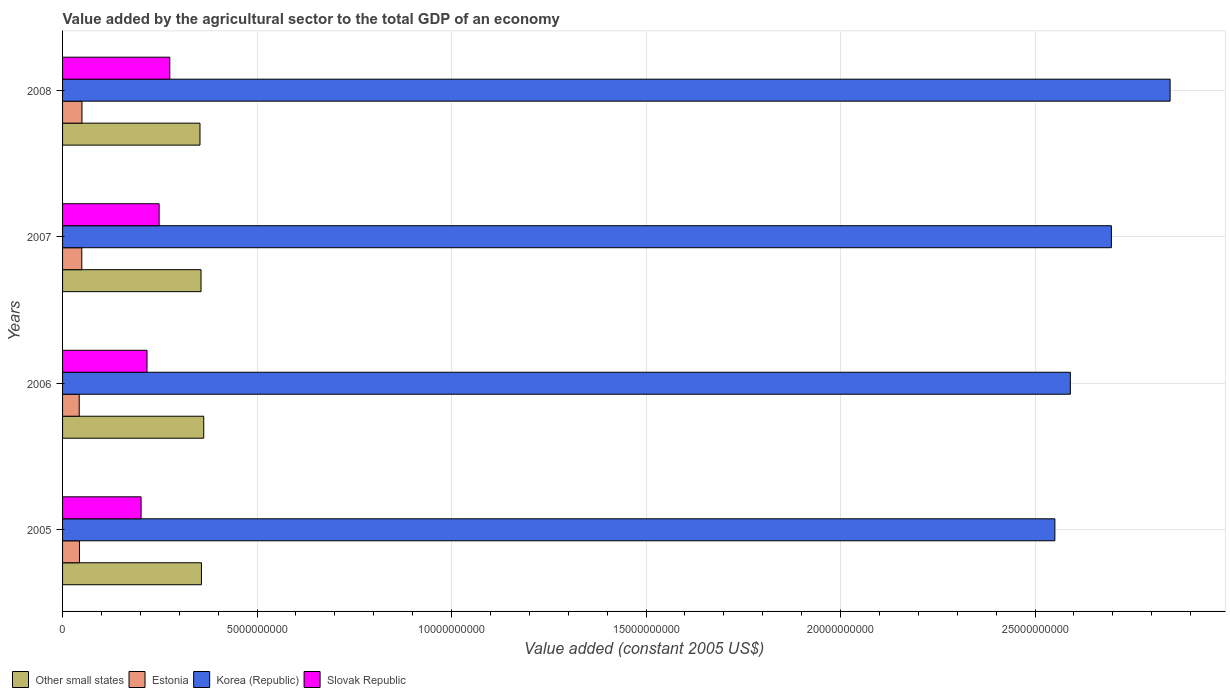Are the number of bars per tick equal to the number of legend labels?
Ensure brevity in your answer.  Yes. Are the number of bars on each tick of the Y-axis equal?
Ensure brevity in your answer.  Yes. How many bars are there on the 4th tick from the top?
Provide a short and direct response. 4. In how many cases, is the number of bars for a given year not equal to the number of legend labels?
Provide a short and direct response. 0. What is the value added by the agricultural sector in Korea (Republic) in 2005?
Your answer should be compact. 2.55e+1. Across all years, what is the maximum value added by the agricultural sector in Slovak Republic?
Provide a succinct answer. 2.76e+09. Across all years, what is the minimum value added by the agricultural sector in Estonia?
Your response must be concise. 4.28e+08. In which year was the value added by the agricultural sector in Slovak Republic maximum?
Give a very brief answer. 2008. In which year was the value added by the agricultural sector in Other small states minimum?
Your answer should be compact. 2008. What is the total value added by the agricultural sector in Slovak Republic in the graph?
Provide a succinct answer. 9.43e+09. What is the difference between the value added by the agricultural sector in Estonia in 2005 and that in 2007?
Your answer should be compact. -6.01e+07. What is the difference between the value added by the agricultural sector in Estonia in 2006 and the value added by the agricultural sector in Slovak Republic in 2008?
Offer a very short reply. -2.33e+09. What is the average value added by the agricultural sector in Other small states per year?
Your response must be concise. 3.57e+09. In the year 2008, what is the difference between the value added by the agricultural sector in Slovak Republic and value added by the agricultural sector in Estonia?
Your response must be concise. 2.26e+09. What is the ratio of the value added by the agricultural sector in Other small states in 2007 to that in 2008?
Your answer should be compact. 1.01. Is the value added by the agricultural sector in Estonia in 2007 less than that in 2008?
Ensure brevity in your answer.  Yes. Is the difference between the value added by the agricultural sector in Slovak Republic in 2005 and 2007 greater than the difference between the value added by the agricultural sector in Estonia in 2005 and 2007?
Your answer should be very brief. No. What is the difference between the highest and the second highest value added by the agricultural sector in Slovak Republic?
Provide a short and direct response. 2.74e+08. What is the difference between the highest and the lowest value added by the agricultural sector in Korea (Republic)?
Give a very brief answer. 2.96e+09. Is the sum of the value added by the agricultural sector in Estonia in 2005 and 2006 greater than the maximum value added by the agricultural sector in Other small states across all years?
Your answer should be compact. No. Is it the case that in every year, the sum of the value added by the agricultural sector in Other small states and value added by the agricultural sector in Korea (Republic) is greater than the sum of value added by the agricultural sector in Estonia and value added by the agricultural sector in Slovak Republic?
Give a very brief answer. Yes. What does the 4th bar from the top in 2008 represents?
Provide a succinct answer. Other small states. What does the 1st bar from the bottom in 2008 represents?
Provide a succinct answer. Other small states. Is it the case that in every year, the sum of the value added by the agricultural sector in Slovak Republic and value added by the agricultural sector in Estonia is greater than the value added by the agricultural sector in Korea (Republic)?
Ensure brevity in your answer.  No. How many bars are there?
Make the answer very short. 16. Are all the bars in the graph horizontal?
Give a very brief answer. Yes. How many years are there in the graph?
Make the answer very short. 4. What is the difference between two consecutive major ticks on the X-axis?
Give a very brief answer. 5.00e+09. Does the graph contain any zero values?
Your response must be concise. No. Where does the legend appear in the graph?
Ensure brevity in your answer.  Bottom left. How are the legend labels stacked?
Ensure brevity in your answer.  Horizontal. What is the title of the graph?
Your answer should be compact. Value added by the agricultural sector to the total GDP of an economy. What is the label or title of the X-axis?
Offer a very short reply. Value added (constant 2005 US$). What is the Value added (constant 2005 US$) of Other small states in 2005?
Your response must be concise. 3.57e+09. What is the Value added (constant 2005 US$) of Estonia in 2005?
Provide a succinct answer. 4.34e+08. What is the Value added (constant 2005 US$) of Korea (Republic) in 2005?
Give a very brief answer. 2.55e+1. What is the Value added (constant 2005 US$) in Slovak Republic in 2005?
Ensure brevity in your answer.  2.02e+09. What is the Value added (constant 2005 US$) of Other small states in 2006?
Ensure brevity in your answer.  3.63e+09. What is the Value added (constant 2005 US$) of Estonia in 2006?
Ensure brevity in your answer.  4.28e+08. What is the Value added (constant 2005 US$) of Korea (Republic) in 2006?
Ensure brevity in your answer.  2.59e+1. What is the Value added (constant 2005 US$) in Slovak Republic in 2006?
Make the answer very short. 2.17e+09. What is the Value added (constant 2005 US$) in Other small states in 2007?
Keep it short and to the point. 3.56e+09. What is the Value added (constant 2005 US$) in Estonia in 2007?
Offer a very short reply. 4.94e+08. What is the Value added (constant 2005 US$) of Korea (Republic) in 2007?
Your answer should be compact. 2.70e+1. What is the Value added (constant 2005 US$) of Slovak Republic in 2007?
Offer a terse response. 2.48e+09. What is the Value added (constant 2005 US$) of Other small states in 2008?
Offer a terse response. 3.53e+09. What is the Value added (constant 2005 US$) in Estonia in 2008?
Provide a short and direct response. 4.99e+08. What is the Value added (constant 2005 US$) in Korea (Republic) in 2008?
Ensure brevity in your answer.  2.85e+1. What is the Value added (constant 2005 US$) in Slovak Republic in 2008?
Your response must be concise. 2.76e+09. Across all years, what is the maximum Value added (constant 2005 US$) of Other small states?
Your response must be concise. 3.63e+09. Across all years, what is the maximum Value added (constant 2005 US$) of Estonia?
Give a very brief answer. 4.99e+08. Across all years, what is the maximum Value added (constant 2005 US$) in Korea (Republic)?
Keep it short and to the point. 2.85e+1. Across all years, what is the maximum Value added (constant 2005 US$) of Slovak Republic?
Keep it short and to the point. 2.76e+09. Across all years, what is the minimum Value added (constant 2005 US$) of Other small states?
Offer a terse response. 3.53e+09. Across all years, what is the minimum Value added (constant 2005 US$) in Estonia?
Provide a short and direct response. 4.28e+08. Across all years, what is the minimum Value added (constant 2005 US$) in Korea (Republic)?
Provide a succinct answer. 2.55e+1. Across all years, what is the minimum Value added (constant 2005 US$) of Slovak Republic?
Make the answer very short. 2.02e+09. What is the total Value added (constant 2005 US$) in Other small states in the graph?
Offer a terse response. 1.43e+1. What is the total Value added (constant 2005 US$) in Estonia in the graph?
Provide a succinct answer. 1.86e+09. What is the total Value added (constant 2005 US$) in Korea (Republic) in the graph?
Ensure brevity in your answer.  1.07e+11. What is the total Value added (constant 2005 US$) in Slovak Republic in the graph?
Your response must be concise. 9.43e+09. What is the difference between the Value added (constant 2005 US$) of Other small states in 2005 and that in 2006?
Offer a terse response. -5.84e+07. What is the difference between the Value added (constant 2005 US$) of Estonia in 2005 and that in 2006?
Offer a very short reply. 5.99e+06. What is the difference between the Value added (constant 2005 US$) in Korea (Republic) in 2005 and that in 2006?
Your response must be concise. -3.98e+08. What is the difference between the Value added (constant 2005 US$) of Slovak Republic in 2005 and that in 2006?
Give a very brief answer. -1.52e+08. What is the difference between the Value added (constant 2005 US$) in Other small states in 2005 and that in 2007?
Your answer should be compact. 1.07e+07. What is the difference between the Value added (constant 2005 US$) of Estonia in 2005 and that in 2007?
Your answer should be very brief. -6.01e+07. What is the difference between the Value added (constant 2005 US$) of Korea (Republic) in 2005 and that in 2007?
Your response must be concise. -1.45e+09. What is the difference between the Value added (constant 2005 US$) in Slovak Republic in 2005 and that in 2007?
Ensure brevity in your answer.  -4.64e+08. What is the difference between the Value added (constant 2005 US$) in Other small states in 2005 and that in 2008?
Make the answer very short. 3.79e+07. What is the difference between the Value added (constant 2005 US$) of Estonia in 2005 and that in 2008?
Offer a very short reply. -6.44e+07. What is the difference between the Value added (constant 2005 US$) in Korea (Republic) in 2005 and that in 2008?
Your answer should be compact. -2.96e+09. What is the difference between the Value added (constant 2005 US$) of Slovak Republic in 2005 and that in 2008?
Your answer should be very brief. -7.38e+08. What is the difference between the Value added (constant 2005 US$) of Other small states in 2006 and that in 2007?
Offer a terse response. 6.91e+07. What is the difference between the Value added (constant 2005 US$) in Estonia in 2006 and that in 2007?
Your answer should be compact. -6.61e+07. What is the difference between the Value added (constant 2005 US$) in Korea (Republic) in 2006 and that in 2007?
Your response must be concise. -1.05e+09. What is the difference between the Value added (constant 2005 US$) of Slovak Republic in 2006 and that in 2007?
Make the answer very short. -3.12e+08. What is the difference between the Value added (constant 2005 US$) in Other small states in 2006 and that in 2008?
Offer a very short reply. 9.63e+07. What is the difference between the Value added (constant 2005 US$) of Estonia in 2006 and that in 2008?
Keep it short and to the point. -7.04e+07. What is the difference between the Value added (constant 2005 US$) in Korea (Republic) in 2006 and that in 2008?
Your answer should be compact. -2.56e+09. What is the difference between the Value added (constant 2005 US$) in Slovak Republic in 2006 and that in 2008?
Ensure brevity in your answer.  -5.86e+08. What is the difference between the Value added (constant 2005 US$) in Other small states in 2007 and that in 2008?
Make the answer very short. 2.72e+07. What is the difference between the Value added (constant 2005 US$) of Estonia in 2007 and that in 2008?
Offer a terse response. -4.29e+06. What is the difference between the Value added (constant 2005 US$) of Korea (Republic) in 2007 and that in 2008?
Offer a very short reply. -1.51e+09. What is the difference between the Value added (constant 2005 US$) in Slovak Republic in 2007 and that in 2008?
Offer a terse response. -2.74e+08. What is the difference between the Value added (constant 2005 US$) of Other small states in 2005 and the Value added (constant 2005 US$) of Estonia in 2006?
Make the answer very short. 3.14e+09. What is the difference between the Value added (constant 2005 US$) of Other small states in 2005 and the Value added (constant 2005 US$) of Korea (Republic) in 2006?
Your response must be concise. -2.23e+1. What is the difference between the Value added (constant 2005 US$) of Other small states in 2005 and the Value added (constant 2005 US$) of Slovak Republic in 2006?
Ensure brevity in your answer.  1.40e+09. What is the difference between the Value added (constant 2005 US$) in Estonia in 2005 and the Value added (constant 2005 US$) in Korea (Republic) in 2006?
Provide a succinct answer. -2.55e+1. What is the difference between the Value added (constant 2005 US$) of Estonia in 2005 and the Value added (constant 2005 US$) of Slovak Republic in 2006?
Your answer should be compact. -1.74e+09. What is the difference between the Value added (constant 2005 US$) in Korea (Republic) in 2005 and the Value added (constant 2005 US$) in Slovak Republic in 2006?
Offer a terse response. 2.33e+1. What is the difference between the Value added (constant 2005 US$) of Other small states in 2005 and the Value added (constant 2005 US$) of Estonia in 2007?
Offer a very short reply. 3.08e+09. What is the difference between the Value added (constant 2005 US$) of Other small states in 2005 and the Value added (constant 2005 US$) of Korea (Republic) in 2007?
Offer a very short reply. -2.34e+1. What is the difference between the Value added (constant 2005 US$) in Other small states in 2005 and the Value added (constant 2005 US$) in Slovak Republic in 2007?
Your answer should be compact. 1.09e+09. What is the difference between the Value added (constant 2005 US$) in Estonia in 2005 and the Value added (constant 2005 US$) in Korea (Republic) in 2007?
Offer a terse response. -2.65e+1. What is the difference between the Value added (constant 2005 US$) in Estonia in 2005 and the Value added (constant 2005 US$) in Slovak Republic in 2007?
Provide a short and direct response. -2.05e+09. What is the difference between the Value added (constant 2005 US$) of Korea (Republic) in 2005 and the Value added (constant 2005 US$) of Slovak Republic in 2007?
Offer a terse response. 2.30e+1. What is the difference between the Value added (constant 2005 US$) in Other small states in 2005 and the Value added (constant 2005 US$) in Estonia in 2008?
Your response must be concise. 3.07e+09. What is the difference between the Value added (constant 2005 US$) of Other small states in 2005 and the Value added (constant 2005 US$) of Korea (Republic) in 2008?
Offer a terse response. -2.49e+1. What is the difference between the Value added (constant 2005 US$) of Other small states in 2005 and the Value added (constant 2005 US$) of Slovak Republic in 2008?
Provide a short and direct response. 8.14e+08. What is the difference between the Value added (constant 2005 US$) in Estonia in 2005 and the Value added (constant 2005 US$) in Korea (Republic) in 2008?
Your answer should be compact. -2.80e+1. What is the difference between the Value added (constant 2005 US$) in Estonia in 2005 and the Value added (constant 2005 US$) in Slovak Republic in 2008?
Your answer should be compact. -2.32e+09. What is the difference between the Value added (constant 2005 US$) of Korea (Republic) in 2005 and the Value added (constant 2005 US$) of Slovak Republic in 2008?
Make the answer very short. 2.28e+1. What is the difference between the Value added (constant 2005 US$) of Other small states in 2006 and the Value added (constant 2005 US$) of Estonia in 2007?
Your response must be concise. 3.13e+09. What is the difference between the Value added (constant 2005 US$) of Other small states in 2006 and the Value added (constant 2005 US$) of Korea (Republic) in 2007?
Provide a short and direct response. -2.33e+1. What is the difference between the Value added (constant 2005 US$) in Other small states in 2006 and the Value added (constant 2005 US$) in Slovak Republic in 2007?
Make the answer very short. 1.15e+09. What is the difference between the Value added (constant 2005 US$) of Estonia in 2006 and the Value added (constant 2005 US$) of Korea (Republic) in 2007?
Offer a terse response. -2.65e+1. What is the difference between the Value added (constant 2005 US$) of Estonia in 2006 and the Value added (constant 2005 US$) of Slovak Republic in 2007?
Make the answer very short. -2.05e+09. What is the difference between the Value added (constant 2005 US$) in Korea (Republic) in 2006 and the Value added (constant 2005 US$) in Slovak Republic in 2007?
Give a very brief answer. 2.34e+1. What is the difference between the Value added (constant 2005 US$) of Other small states in 2006 and the Value added (constant 2005 US$) of Estonia in 2008?
Your answer should be compact. 3.13e+09. What is the difference between the Value added (constant 2005 US$) of Other small states in 2006 and the Value added (constant 2005 US$) of Korea (Republic) in 2008?
Provide a succinct answer. -2.48e+1. What is the difference between the Value added (constant 2005 US$) in Other small states in 2006 and the Value added (constant 2005 US$) in Slovak Republic in 2008?
Give a very brief answer. 8.72e+08. What is the difference between the Value added (constant 2005 US$) of Estonia in 2006 and the Value added (constant 2005 US$) of Korea (Republic) in 2008?
Make the answer very short. -2.80e+1. What is the difference between the Value added (constant 2005 US$) in Estonia in 2006 and the Value added (constant 2005 US$) in Slovak Republic in 2008?
Offer a very short reply. -2.33e+09. What is the difference between the Value added (constant 2005 US$) of Korea (Republic) in 2006 and the Value added (constant 2005 US$) of Slovak Republic in 2008?
Provide a short and direct response. 2.32e+1. What is the difference between the Value added (constant 2005 US$) of Other small states in 2007 and the Value added (constant 2005 US$) of Estonia in 2008?
Your answer should be compact. 3.06e+09. What is the difference between the Value added (constant 2005 US$) of Other small states in 2007 and the Value added (constant 2005 US$) of Korea (Republic) in 2008?
Keep it short and to the point. -2.49e+1. What is the difference between the Value added (constant 2005 US$) in Other small states in 2007 and the Value added (constant 2005 US$) in Slovak Republic in 2008?
Provide a succinct answer. 8.03e+08. What is the difference between the Value added (constant 2005 US$) of Estonia in 2007 and the Value added (constant 2005 US$) of Korea (Republic) in 2008?
Your answer should be very brief. -2.80e+1. What is the difference between the Value added (constant 2005 US$) of Estonia in 2007 and the Value added (constant 2005 US$) of Slovak Republic in 2008?
Ensure brevity in your answer.  -2.26e+09. What is the difference between the Value added (constant 2005 US$) of Korea (Republic) in 2007 and the Value added (constant 2005 US$) of Slovak Republic in 2008?
Keep it short and to the point. 2.42e+1. What is the average Value added (constant 2005 US$) in Other small states per year?
Ensure brevity in your answer.  3.57e+09. What is the average Value added (constant 2005 US$) of Estonia per year?
Ensure brevity in your answer.  4.64e+08. What is the average Value added (constant 2005 US$) in Korea (Republic) per year?
Provide a short and direct response. 2.67e+1. What is the average Value added (constant 2005 US$) of Slovak Republic per year?
Your answer should be very brief. 2.36e+09. In the year 2005, what is the difference between the Value added (constant 2005 US$) of Other small states and Value added (constant 2005 US$) of Estonia?
Your answer should be compact. 3.14e+09. In the year 2005, what is the difference between the Value added (constant 2005 US$) in Other small states and Value added (constant 2005 US$) in Korea (Republic)?
Ensure brevity in your answer.  -2.19e+1. In the year 2005, what is the difference between the Value added (constant 2005 US$) in Other small states and Value added (constant 2005 US$) in Slovak Republic?
Your answer should be compact. 1.55e+09. In the year 2005, what is the difference between the Value added (constant 2005 US$) of Estonia and Value added (constant 2005 US$) of Korea (Republic)?
Provide a short and direct response. -2.51e+1. In the year 2005, what is the difference between the Value added (constant 2005 US$) in Estonia and Value added (constant 2005 US$) in Slovak Republic?
Your response must be concise. -1.58e+09. In the year 2005, what is the difference between the Value added (constant 2005 US$) of Korea (Republic) and Value added (constant 2005 US$) of Slovak Republic?
Provide a succinct answer. 2.35e+1. In the year 2006, what is the difference between the Value added (constant 2005 US$) in Other small states and Value added (constant 2005 US$) in Estonia?
Ensure brevity in your answer.  3.20e+09. In the year 2006, what is the difference between the Value added (constant 2005 US$) in Other small states and Value added (constant 2005 US$) in Korea (Republic)?
Keep it short and to the point. -2.23e+1. In the year 2006, what is the difference between the Value added (constant 2005 US$) of Other small states and Value added (constant 2005 US$) of Slovak Republic?
Keep it short and to the point. 1.46e+09. In the year 2006, what is the difference between the Value added (constant 2005 US$) in Estonia and Value added (constant 2005 US$) in Korea (Republic)?
Ensure brevity in your answer.  -2.55e+1. In the year 2006, what is the difference between the Value added (constant 2005 US$) of Estonia and Value added (constant 2005 US$) of Slovak Republic?
Your answer should be very brief. -1.74e+09. In the year 2006, what is the difference between the Value added (constant 2005 US$) in Korea (Republic) and Value added (constant 2005 US$) in Slovak Republic?
Provide a short and direct response. 2.37e+1. In the year 2007, what is the difference between the Value added (constant 2005 US$) of Other small states and Value added (constant 2005 US$) of Estonia?
Make the answer very short. 3.07e+09. In the year 2007, what is the difference between the Value added (constant 2005 US$) of Other small states and Value added (constant 2005 US$) of Korea (Republic)?
Offer a terse response. -2.34e+1. In the year 2007, what is the difference between the Value added (constant 2005 US$) in Other small states and Value added (constant 2005 US$) in Slovak Republic?
Keep it short and to the point. 1.08e+09. In the year 2007, what is the difference between the Value added (constant 2005 US$) in Estonia and Value added (constant 2005 US$) in Korea (Republic)?
Provide a succinct answer. -2.65e+1. In the year 2007, what is the difference between the Value added (constant 2005 US$) in Estonia and Value added (constant 2005 US$) in Slovak Republic?
Provide a short and direct response. -1.99e+09. In the year 2007, what is the difference between the Value added (constant 2005 US$) of Korea (Republic) and Value added (constant 2005 US$) of Slovak Republic?
Your response must be concise. 2.45e+1. In the year 2008, what is the difference between the Value added (constant 2005 US$) of Other small states and Value added (constant 2005 US$) of Estonia?
Ensure brevity in your answer.  3.03e+09. In the year 2008, what is the difference between the Value added (constant 2005 US$) in Other small states and Value added (constant 2005 US$) in Korea (Republic)?
Your answer should be compact. -2.49e+1. In the year 2008, what is the difference between the Value added (constant 2005 US$) in Other small states and Value added (constant 2005 US$) in Slovak Republic?
Ensure brevity in your answer.  7.76e+08. In the year 2008, what is the difference between the Value added (constant 2005 US$) of Estonia and Value added (constant 2005 US$) of Korea (Republic)?
Make the answer very short. -2.80e+1. In the year 2008, what is the difference between the Value added (constant 2005 US$) of Estonia and Value added (constant 2005 US$) of Slovak Republic?
Your answer should be compact. -2.26e+09. In the year 2008, what is the difference between the Value added (constant 2005 US$) in Korea (Republic) and Value added (constant 2005 US$) in Slovak Republic?
Your response must be concise. 2.57e+1. What is the ratio of the Value added (constant 2005 US$) of Other small states in 2005 to that in 2006?
Keep it short and to the point. 0.98. What is the ratio of the Value added (constant 2005 US$) in Estonia in 2005 to that in 2006?
Offer a terse response. 1.01. What is the ratio of the Value added (constant 2005 US$) in Korea (Republic) in 2005 to that in 2006?
Provide a succinct answer. 0.98. What is the ratio of the Value added (constant 2005 US$) of Slovak Republic in 2005 to that in 2006?
Ensure brevity in your answer.  0.93. What is the ratio of the Value added (constant 2005 US$) of Other small states in 2005 to that in 2007?
Provide a short and direct response. 1. What is the ratio of the Value added (constant 2005 US$) in Estonia in 2005 to that in 2007?
Give a very brief answer. 0.88. What is the ratio of the Value added (constant 2005 US$) in Korea (Republic) in 2005 to that in 2007?
Offer a terse response. 0.95. What is the ratio of the Value added (constant 2005 US$) in Slovak Republic in 2005 to that in 2007?
Offer a very short reply. 0.81. What is the ratio of the Value added (constant 2005 US$) in Other small states in 2005 to that in 2008?
Your response must be concise. 1.01. What is the ratio of the Value added (constant 2005 US$) of Estonia in 2005 to that in 2008?
Ensure brevity in your answer.  0.87. What is the ratio of the Value added (constant 2005 US$) in Korea (Republic) in 2005 to that in 2008?
Give a very brief answer. 0.9. What is the ratio of the Value added (constant 2005 US$) in Slovak Republic in 2005 to that in 2008?
Your answer should be very brief. 0.73. What is the ratio of the Value added (constant 2005 US$) of Other small states in 2006 to that in 2007?
Keep it short and to the point. 1.02. What is the ratio of the Value added (constant 2005 US$) in Estonia in 2006 to that in 2007?
Provide a succinct answer. 0.87. What is the ratio of the Value added (constant 2005 US$) in Korea (Republic) in 2006 to that in 2007?
Your response must be concise. 0.96. What is the ratio of the Value added (constant 2005 US$) of Slovak Republic in 2006 to that in 2007?
Ensure brevity in your answer.  0.87. What is the ratio of the Value added (constant 2005 US$) of Other small states in 2006 to that in 2008?
Make the answer very short. 1.03. What is the ratio of the Value added (constant 2005 US$) of Estonia in 2006 to that in 2008?
Keep it short and to the point. 0.86. What is the ratio of the Value added (constant 2005 US$) in Korea (Republic) in 2006 to that in 2008?
Provide a succinct answer. 0.91. What is the ratio of the Value added (constant 2005 US$) in Slovak Republic in 2006 to that in 2008?
Provide a succinct answer. 0.79. What is the ratio of the Value added (constant 2005 US$) in Other small states in 2007 to that in 2008?
Your response must be concise. 1.01. What is the ratio of the Value added (constant 2005 US$) of Korea (Republic) in 2007 to that in 2008?
Give a very brief answer. 0.95. What is the ratio of the Value added (constant 2005 US$) in Slovak Republic in 2007 to that in 2008?
Provide a short and direct response. 0.9. What is the difference between the highest and the second highest Value added (constant 2005 US$) in Other small states?
Make the answer very short. 5.84e+07. What is the difference between the highest and the second highest Value added (constant 2005 US$) of Estonia?
Your answer should be compact. 4.29e+06. What is the difference between the highest and the second highest Value added (constant 2005 US$) in Korea (Republic)?
Make the answer very short. 1.51e+09. What is the difference between the highest and the second highest Value added (constant 2005 US$) of Slovak Republic?
Provide a succinct answer. 2.74e+08. What is the difference between the highest and the lowest Value added (constant 2005 US$) of Other small states?
Your answer should be compact. 9.63e+07. What is the difference between the highest and the lowest Value added (constant 2005 US$) in Estonia?
Provide a short and direct response. 7.04e+07. What is the difference between the highest and the lowest Value added (constant 2005 US$) of Korea (Republic)?
Keep it short and to the point. 2.96e+09. What is the difference between the highest and the lowest Value added (constant 2005 US$) in Slovak Republic?
Provide a succinct answer. 7.38e+08. 